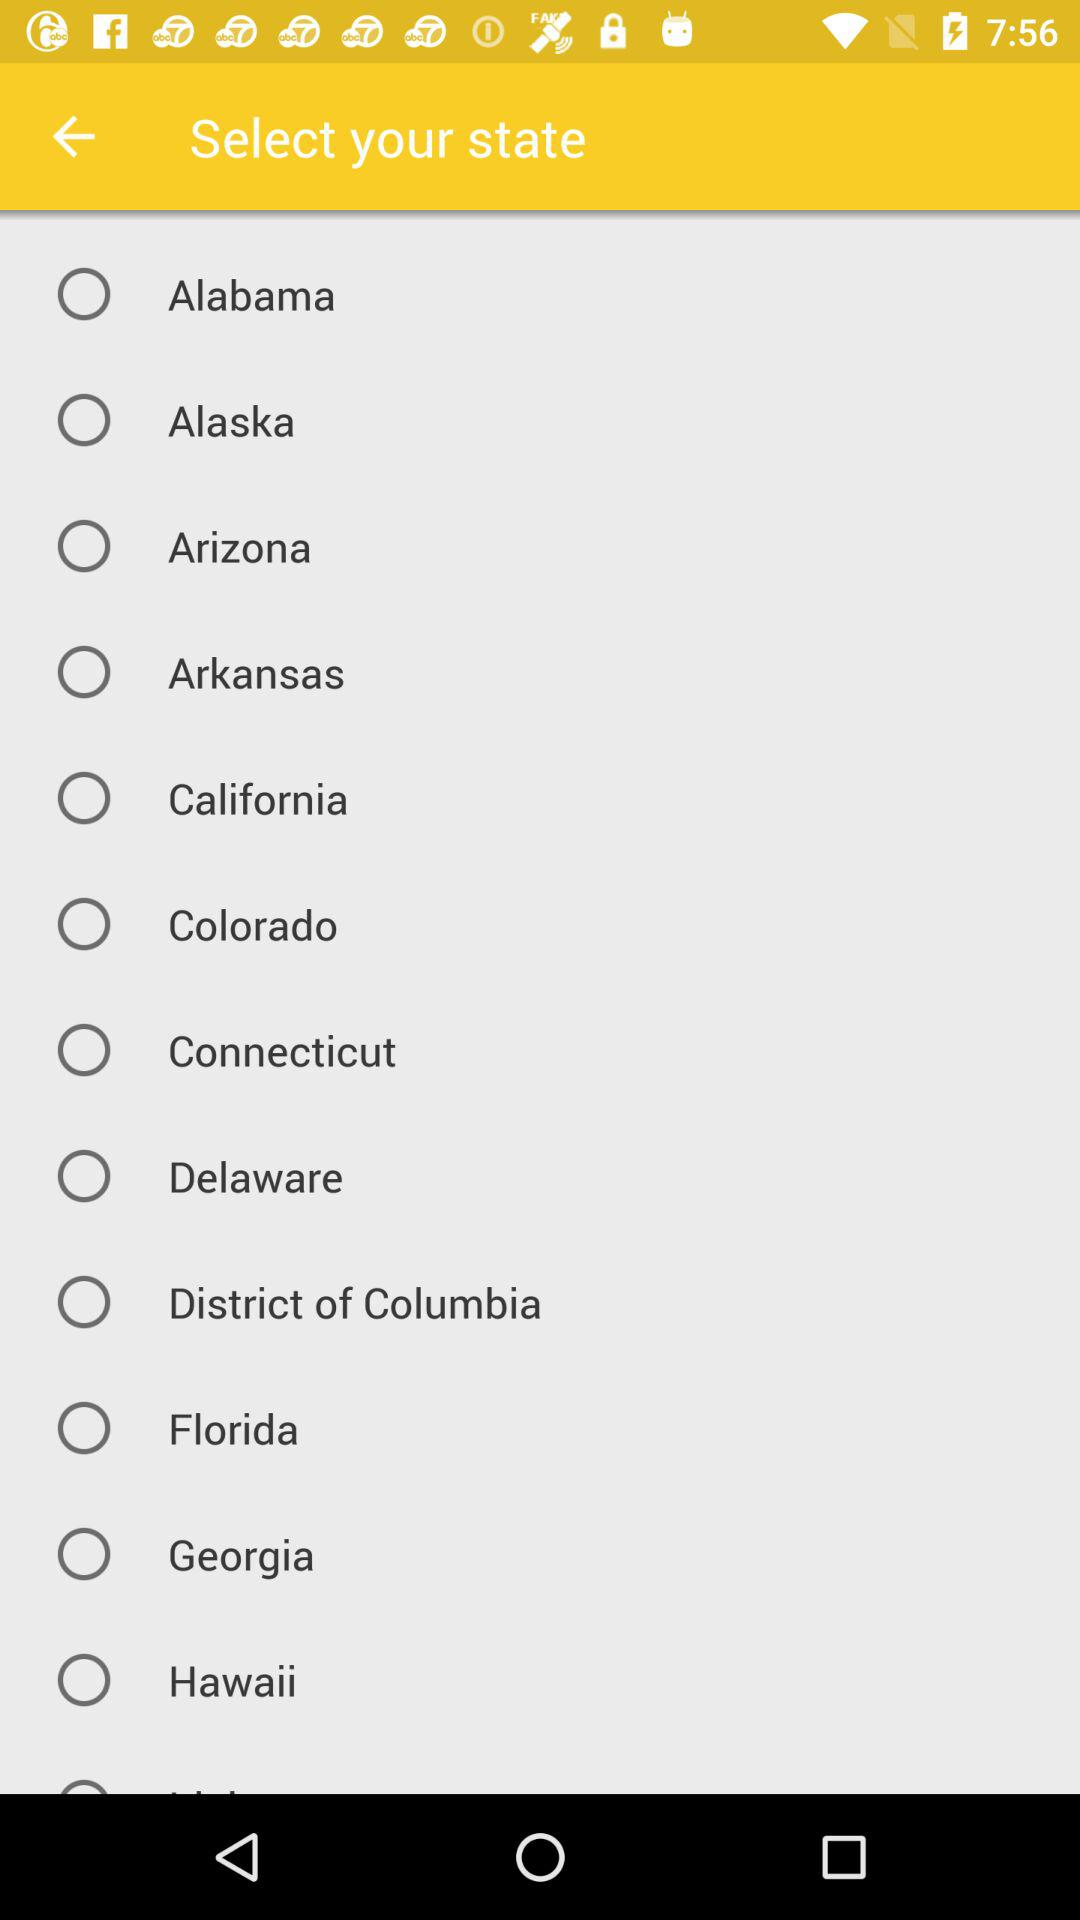Is "Alaska" selected or not? "Alaska" is not selected. 